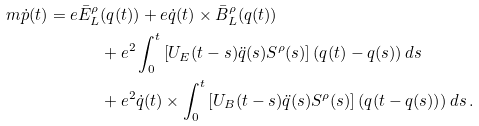Convert formula to latex. <formula><loc_0><loc_0><loc_500><loc_500>m \dot { p } ( t ) = e \bar { E } _ { L } ^ { \rho } & ( q ( t ) ) + e \dot { q } ( t ) \times \bar { B } _ { L } ^ { \rho } ( q ( t ) ) \\ & + e ^ { 2 } \int _ { 0 } ^ { t } \left [ U _ { E } ( t - s ) \ddot { q } ( s ) S ^ { \rho } ( s ) \right ] ( q ( t ) - q ( s ) ) \, d s \\ & + e ^ { 2 } \dot { q } ( t ) \times \int _ { 0 } ^ { t } \left [ U _ { B } ( t - s ) \ddot { q } ( s ) S ^ { \rho } ( s ) \right ] ( q ( t - q ( s ) ) ) \, d s \, .</formula> 